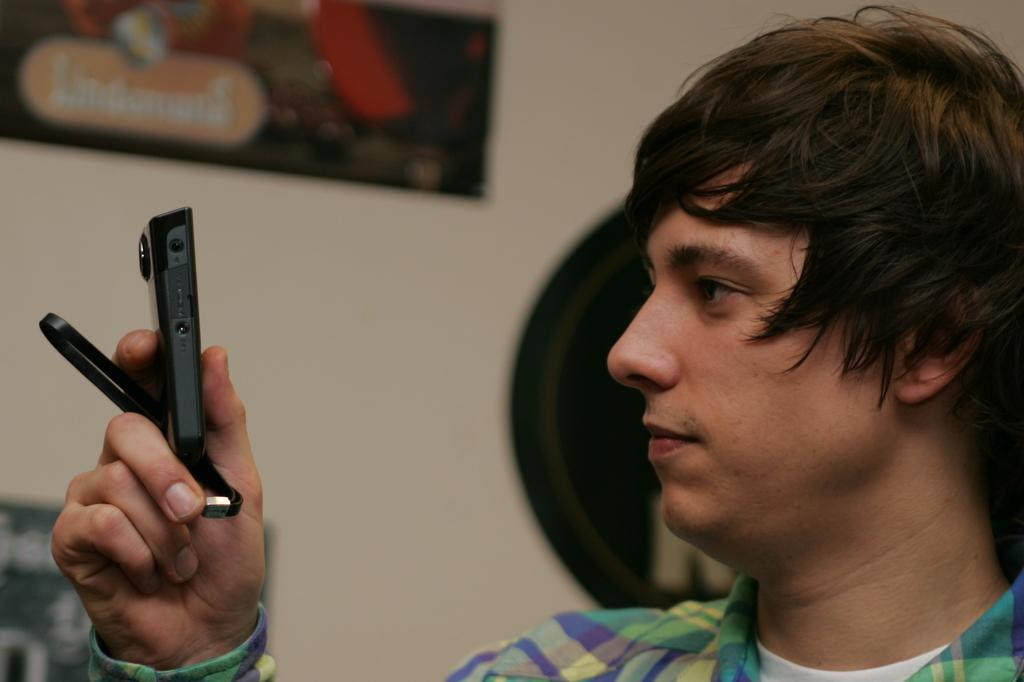Who is present in the image? There is a man in the image. What is the man holding in his hand? The man is holding a device in his hand. Can you describe the man's clothing? The man is wearing a colorful shirt. What can be seen in the background of the image? There is a wall in the background of the image, and there is a poster on the wall. How many sheep are visible in the image? There are no sheep present in the image. What type of cable is the man using to connect the device to the wall? The image does not show any cables, and the man is not connecting the device to the wall. 